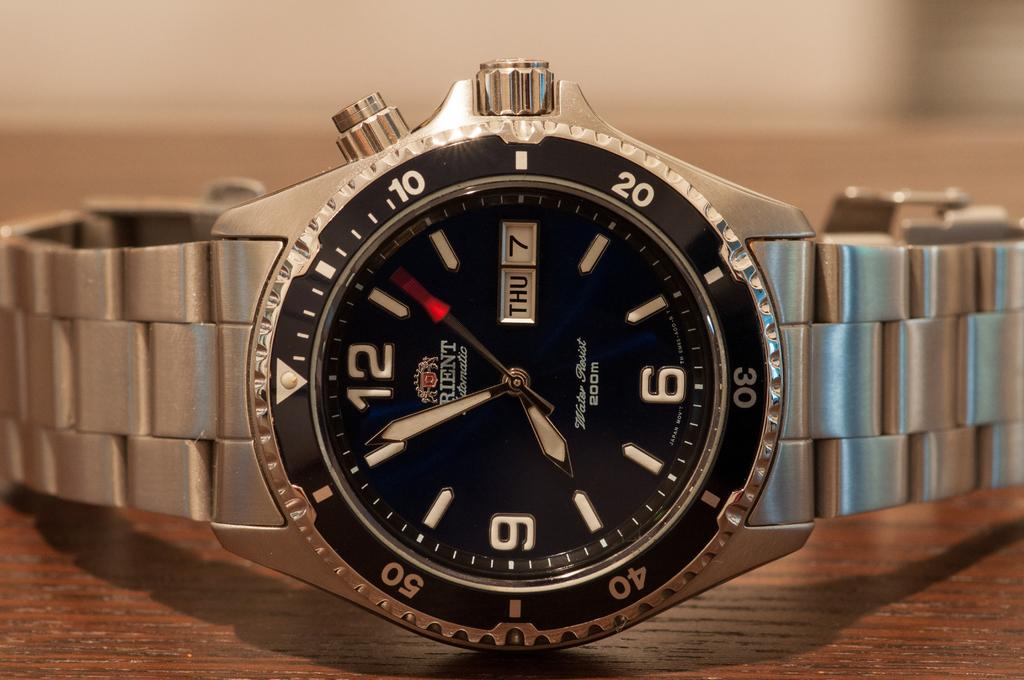What type of object is in the image? There is a metal watch in the image. What is the watch placed on? The metal watch is placed on a brown surface. Where is the ball located in the image? There is no ball present in the image. What type of park can be seen in the background of the image? There is no park visible in the image; it only features a metal watch on a brown surface. 